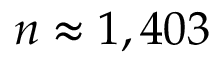Convert formula to latex. <formula><loc_0><loc_0><loc_500><loc_500>n \approx 1 , 4 0 3</formula> 